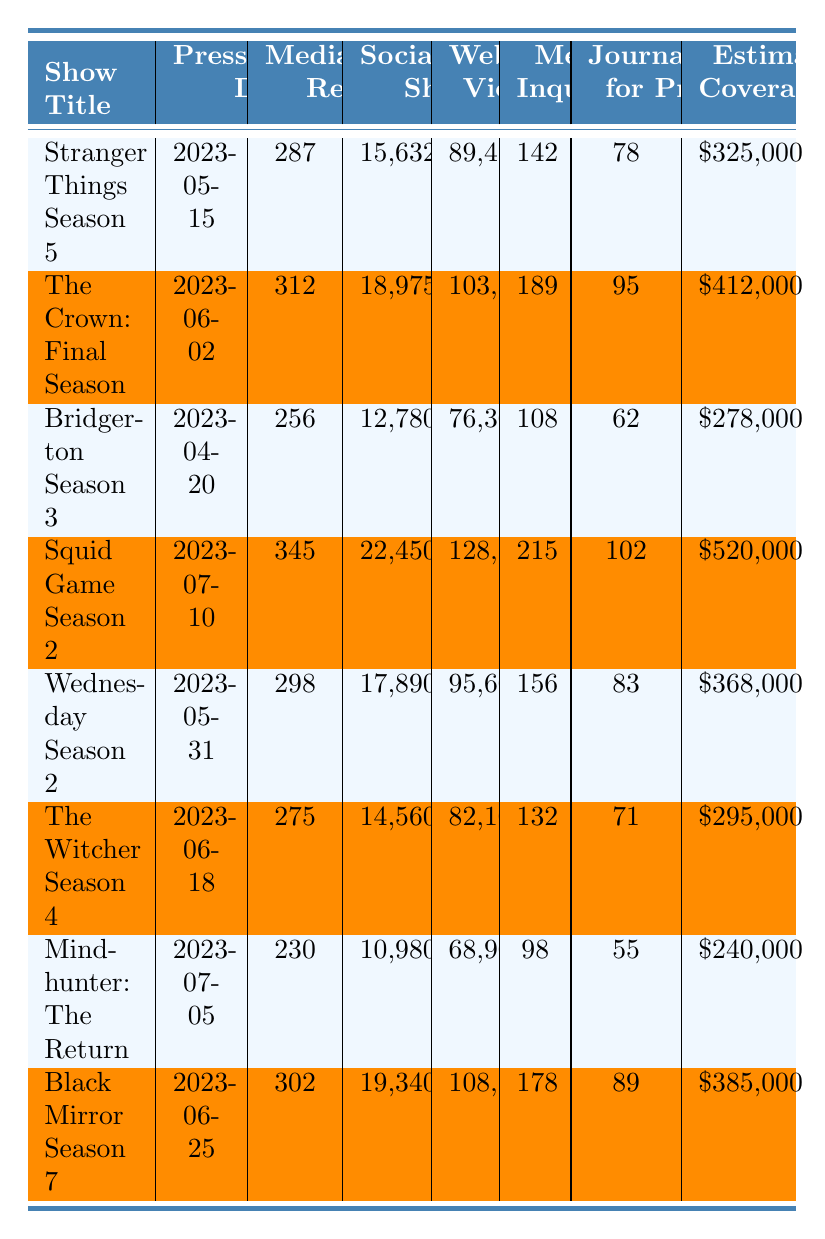What was the press release date for "The Crown: Final Season"? The table lists the press release date under the column "Press Release Date" for each show. For "The Crown: Final Season," the date is indicated as 2023-06-02.
Answer: 2023-06-02 How many media outlets were reached for "Squid Game Season 2"? The number of media outlets reached is found in the "Media Outlets Reached" column. For "Squid Game Season 2," it shows a total of 345 outlets.
Answer: 345 What was the estimated media coverage value for "Mindhunter: The Return"? Looking at the "Estimated Media Coverage Value ($)" column, "Mindhunter: The Return" has a value of $240,000.
Answer: $240,000 Which show had the highest number of social media shares? By comparing the "Social Media Shares" column across all shows, "Squid Game Season 2" had the highest number at 22,450 shares.
Answer: Squid Game Season 2 What is the average number of website views across all shows? To find the average, sum the website views of all shows (89,450 + 103,200 + 76,300 + 128,700 + 95,600 + 82,100 + 68,900 + 108,500 = 764,750) and divide by the number of shows (8), resulting in an average of 95,593.75.
Answer: 95,593.75 Is there a show that had more than 300 media outlets reached? From the "Media Outlets Reached" column, "The Crown: Final Season" (312) and "Squid Game Season 2" (345) both reached more than 300 outlets.
Answer: Yes How many more media inquiries did "The Crown: Final Season" receive compared to "Bridgerton Season 3"? The inquiries for "The Crown: Final Season" were 189 and for "Bridgerton Season 3" were 108, so subtracting gives 189 - 108 = 81 more inquiries.
Answer: 81 Which show had the lowest estimated media coverage value? By examining the "Estimated Media Coverage Value ($)" column, "Mindhunter: The Return" has the lowest value at $240,000.
Answer: Mindhunter: The Return What was the percentage increase in media inquiries from "Wednesday Season 2" to "Squid Game Season 2"? The inquiries for "Wednesday Season 2" were 156 and for "Squid Game Season 2" were 215. The increase is 215 - 156 = 59. The percentage increase is (59/156)*100 ≈ 37.82%.
Answer: 37.82% What show had the most journalist RSVPs for the press event? In the "Journalist RSVPs for Press Event" column, "Squid Game Season 2" shows the highest with 102 RSVPs.
Answer: Squid Game Season 2 